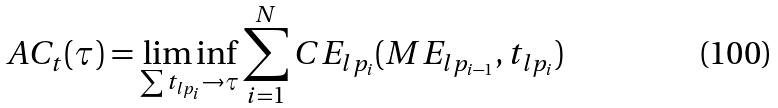Convert formula to latex. <formula><loc_0><loc_0><loc_500><loc_500>A C _ { t } ( \tau ) = \liminf _ { \sum t _ { l p _ { i } } \rightarrow \tau } \sum _ { i = 1 } ^ { N } C E _ { l p _ { i } } ( M E _ { l p _ { i - 1 } } , t _ { l p _ { i } } )</formula> 